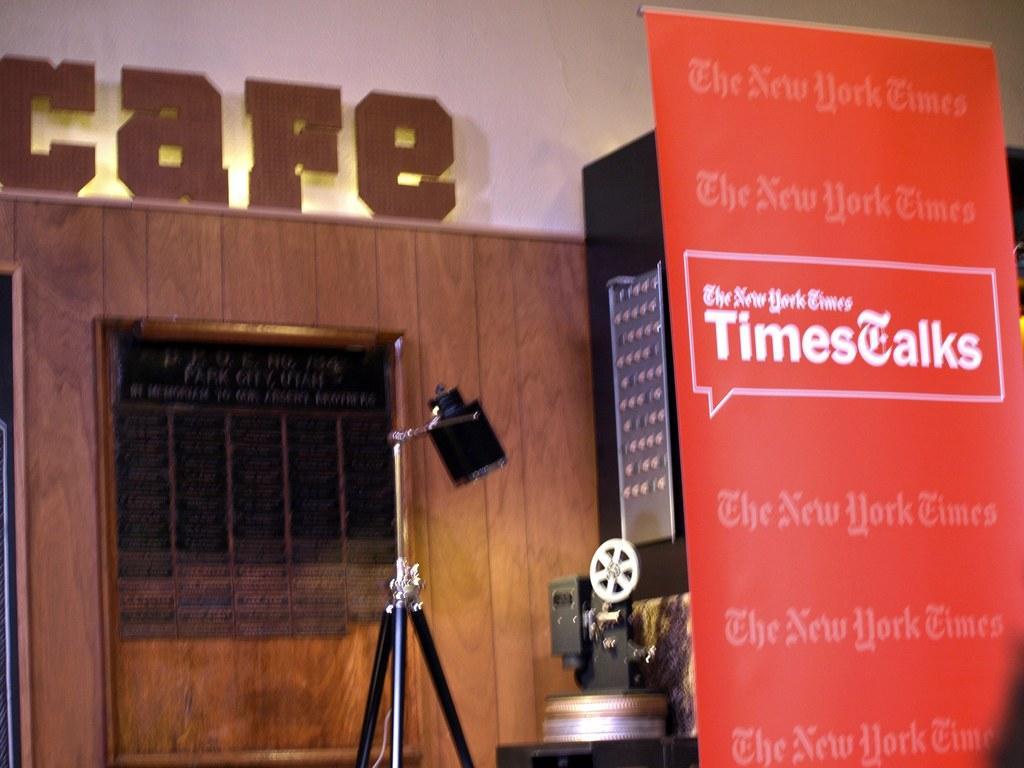How would you summarize this image in a sentence or two? In this picture I can see the banner on the right side. I can see the camera. I can see the camera stand. I can see the wooden wall in the background. 